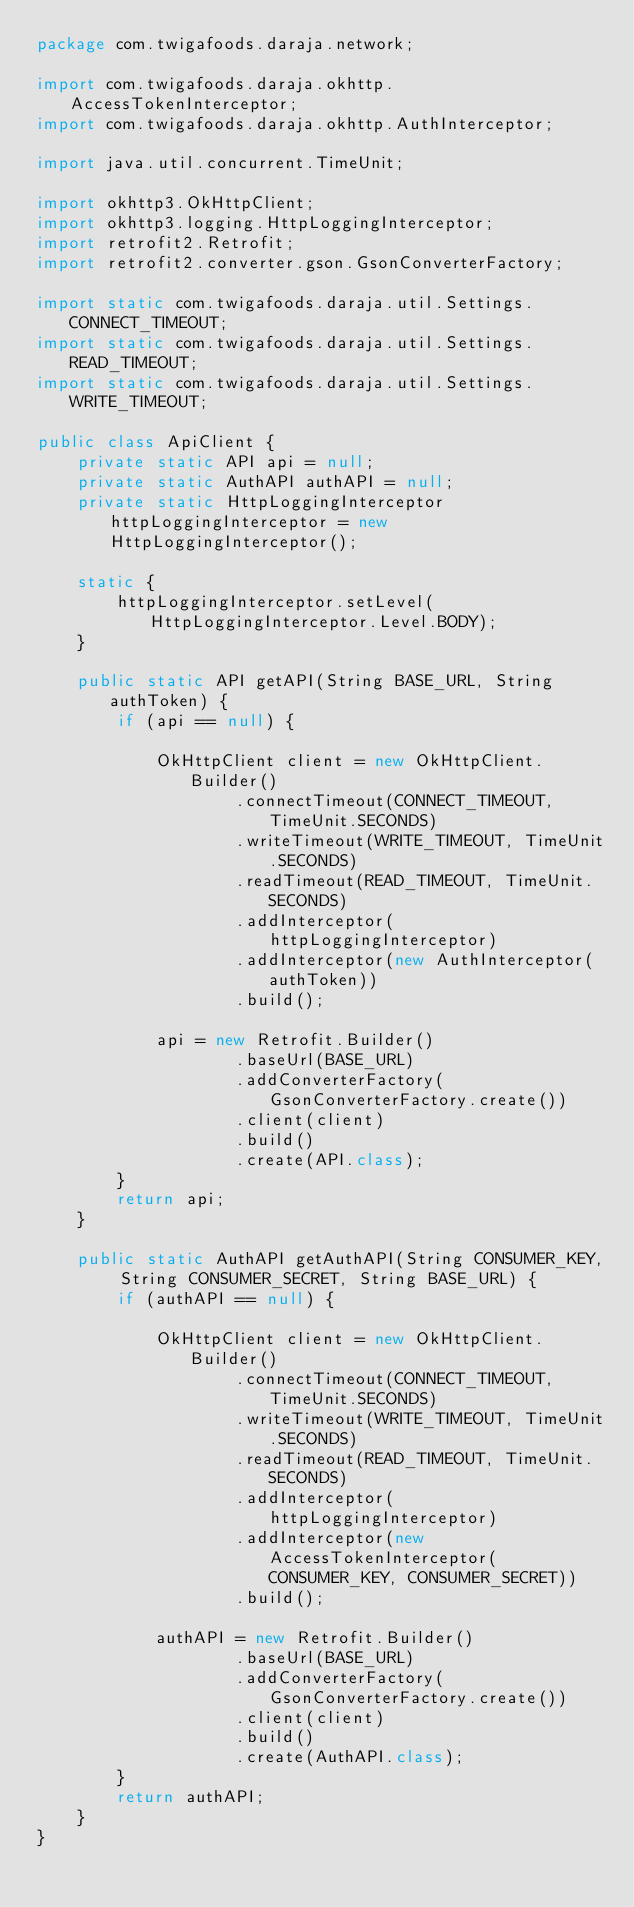<code> <loc_0><loc_0><loc_500><loc_500><_Java_>package com.twigafoods.daraja.network;

import com.twigafoods.daraja.okhttp.AccessTokenInterceptor;
import com.twigafoods.daraja.okhttp.AuthInterceptor;

import java.util.concurrent.TimeUnit;

import okhttp3.OkHttpClient;
import okhttp3.logging.HttpLoggingInterceptor;
import retrofit2.Retrofit;
import retrofit2.converter.gson.GsonConverterFactory;

import static com.twigafoods.daraja.util.Settings.CONNECT_TIMEOUT;
import static com.twigafoods.daraja.util.Settings.READ_TIMEOUT;
import static com.twigafoods.daraja.util.Settings.WRITE_TIMEOUT;

public class ApiClient {
    private static API api = null;
    private static AuthAPI authAPI = null;
    private static HttpLoggingInterceptor httpLoggingInterceptor = new HttpLoggingInterceptor();

    static {
        httpLoggingInterceptor.setLevel(HttpLoggingInterceptor.Level.BODY);
    }

    public static API getAPI(String BASE_URL, String authToken) {
        if (api == null) {

            OkHttpClient client = new OkHttpClient.Builder()
                    .connectTimeout(CONNECT_TIMEOUT, TimeUnit.SECONDS)
                    .writeTimeout(WRITE_TIMEOUT, TimeUnit.SECONDS)
                    .readTimeout(READ_TIMEOUT, TimeUnit.SECONDS)
                    .addInterceptor(httpLoggingInterceptor)
                    .addInterceptor(new AuthInterceptor(authToken))
                    .build();

            api = new Retrofit.Builder()
                    .baseUrl(BASE_URL)
                    .addConverterFactory(GsonConverterFactory.create())
                    .client(client)
                    .build()
                    .create(API.class);
        }
        return api;
    }

    public static AuthAPI getAuthAPI(String CONSUMER_KEY, String CONSUMER_SECRET, String BASE_URL) {
        if (authAPI == null) {

            OkHttpClient client = new OkHttpClient.Builder()
                    .connectTimeout(CONNECT_TIMEOUT, TimeUnit.SECONDS)
                    .writeTimeout(WRITE_TIMEOUT, TimeUnit.SECONDS)
                    .readTimeout(READ_TIMEOUT, TimeUnit.SECONDS)
                    .addInterceptor(httpLoggingInterceptor)
                    .addInterceptor(new AccessTokenInterceptor(CONSUMER_KEY, CONSUMER_SECRET))
                    .build();

            authAPI = new Retrofit.Builder()
                    .baseUrl(BASE_URL)
                    .addConverterFactory(GsonConverterFactory.create())
                    .client(client)
                    .build()
                    .create(AuthAPI.class);
        }
        return authAPI;
    }
}
</code> 